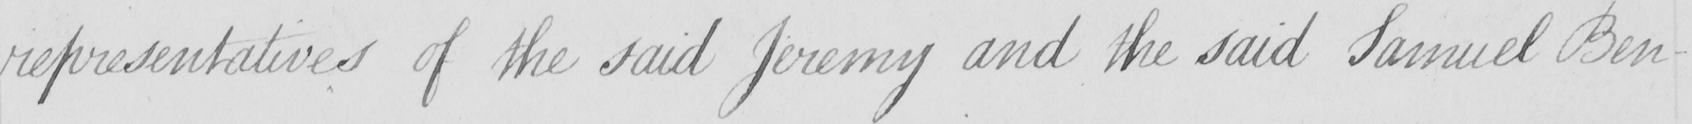Please provide the text content of this handwritten line. representatives of the said Jeremy and the said Samuel Ben- 